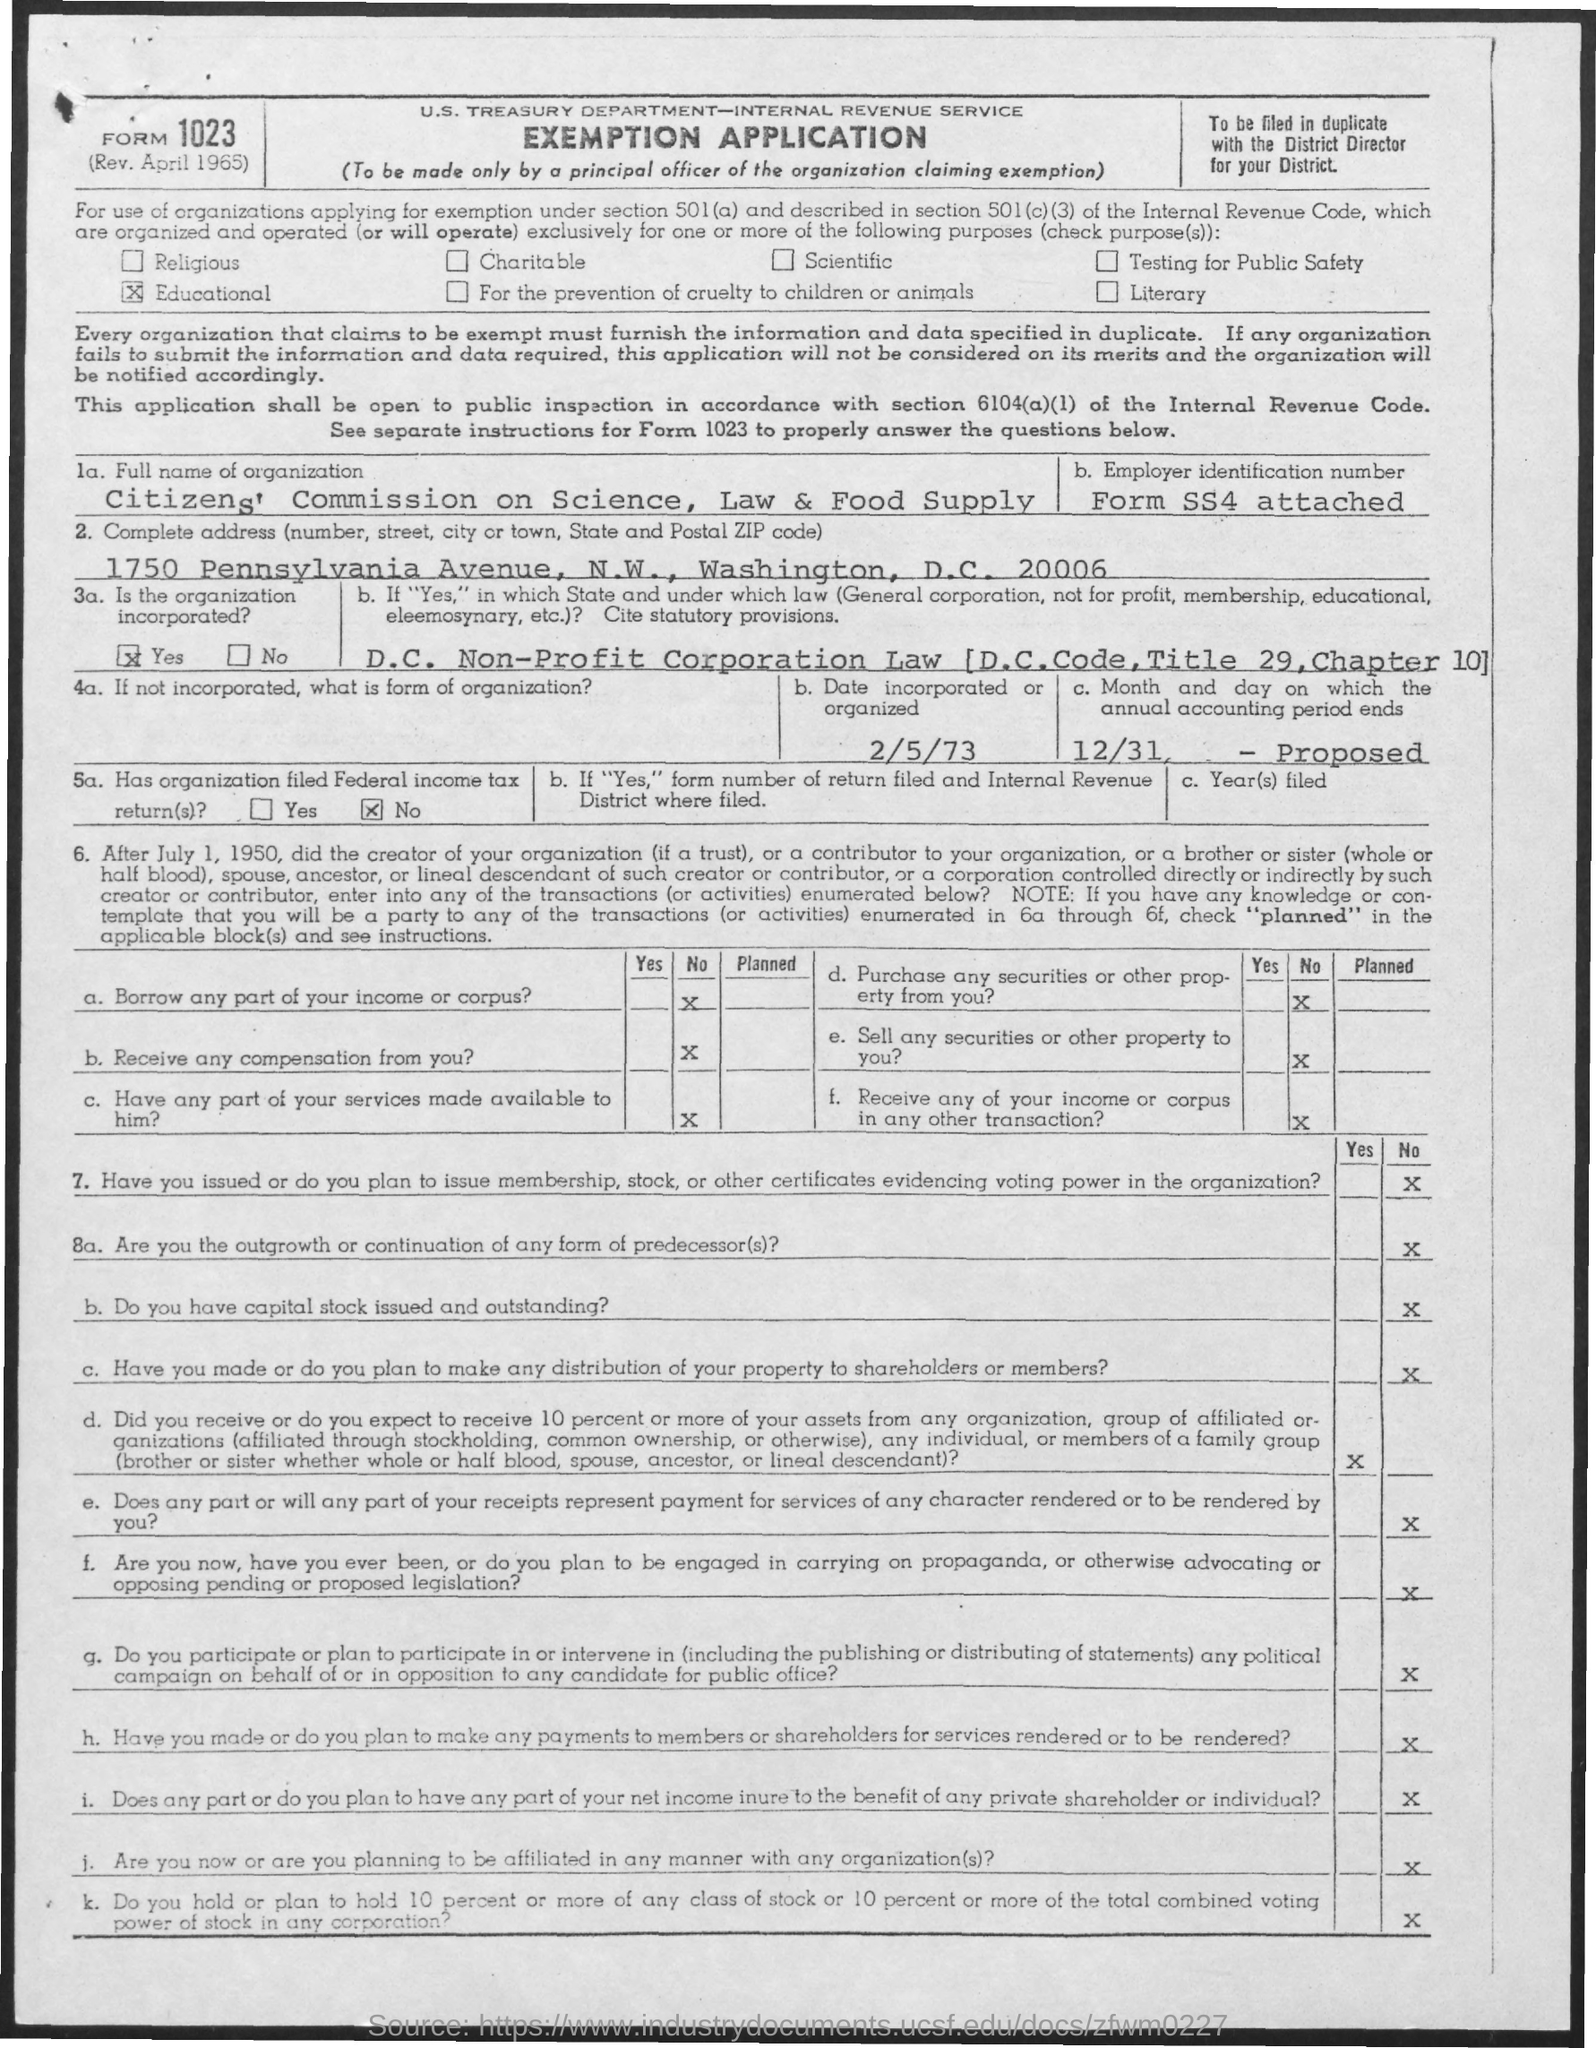What is the date incorporated or organized as given in the application?
Provide a succinct answer. 2/5/73. Has the organization filed Federal income tax return(s)?
Provide a succinct answer. No. What is the Full name of organization as given in the application?
Your response must be concise. Citizens' Commission on Science, Law & Food Supply. 